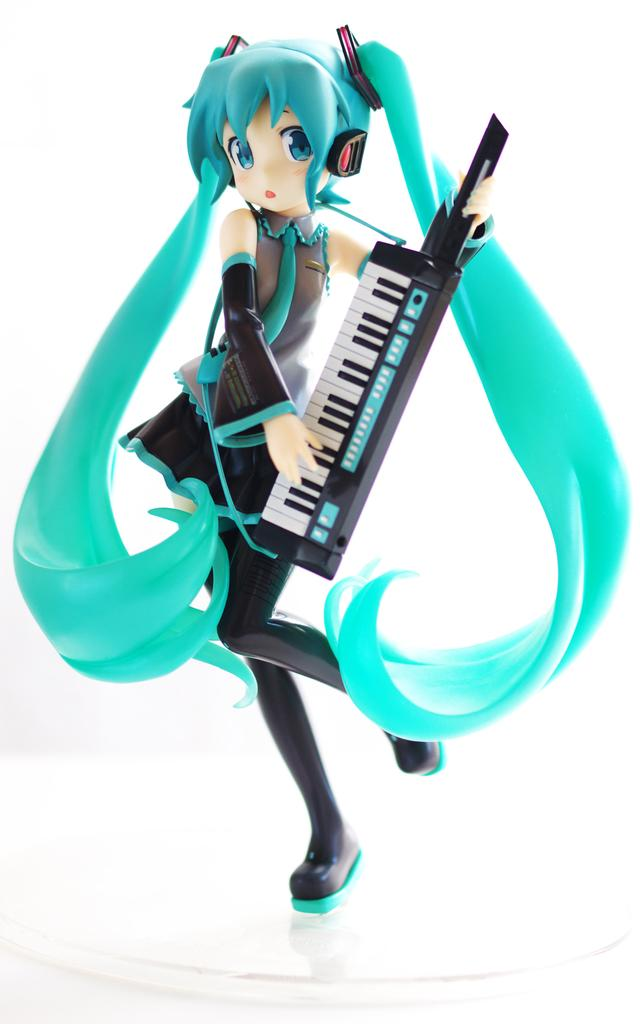What is the main subject of the image? The main subject of the image is an animated picture of a girl. What is the girl holding in her hand? The girl is holding a Casio in her hand. Can you see a giraffe in the image? No, there is no giraffe present in the image. Is there any sleet visible in the image? No, there is no mention of sleet or any weather condition in the image. 